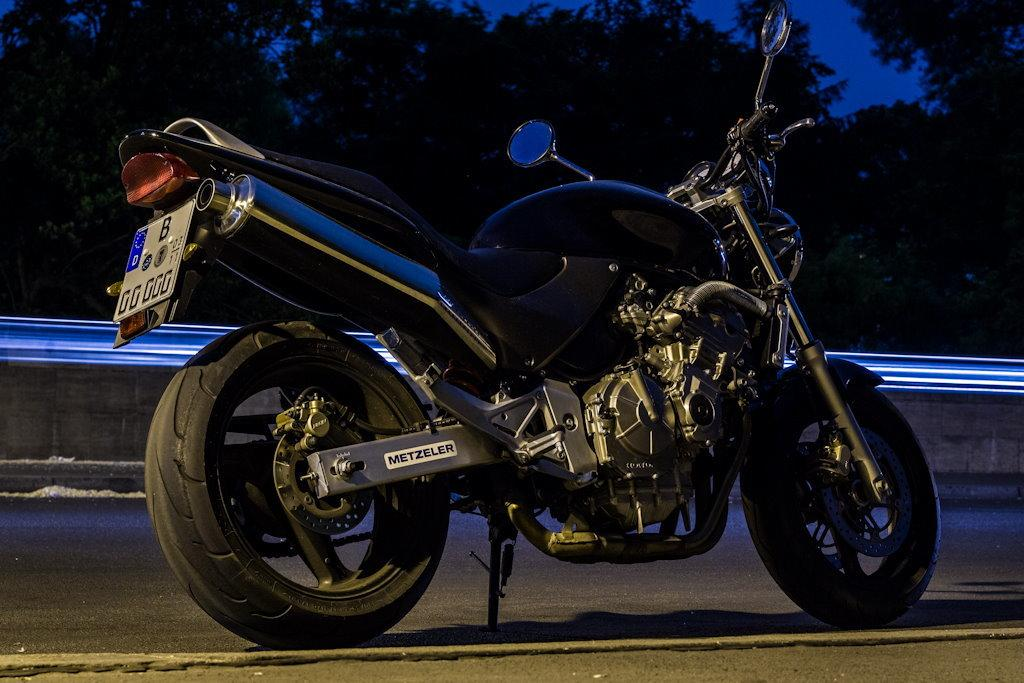What is on the road in the image? There is a bike on the road in the image. What can be seen near the bike? There is a barrier in the image. What type of vegetation is visible in the image? There are trees in the image. What is visible above the bike and barrier? The sky is visible in the image. What type of basket is attached to the neck of the bike in the image? There is no basket or mention of a neck in the image. 